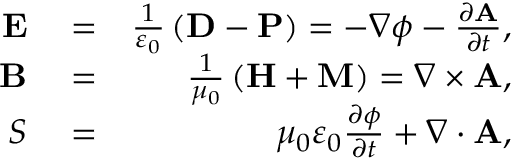Convert formula to latex. <formula><loc_0><loc_0><loc_500><loc_500>\begin{array} { r l r } { E } & = } & { \frac { 1 } { \varepsilon _ { 0 } } \left ( D - P \right ) = - \nabla \phi - \frac { \partial A } { \partial t } , } \\ { B } & = } & { \frac { 1 } { \mu _ { 0 } } \left ( H + M \right ) = \nabla \times A , } \\ { S } & = } & { \mu _ { 0 } \varepsilon _ { 0 } \frac { \partial \phi } { \partial t } + \nabla \cdot A , } \end{array}</formula> 